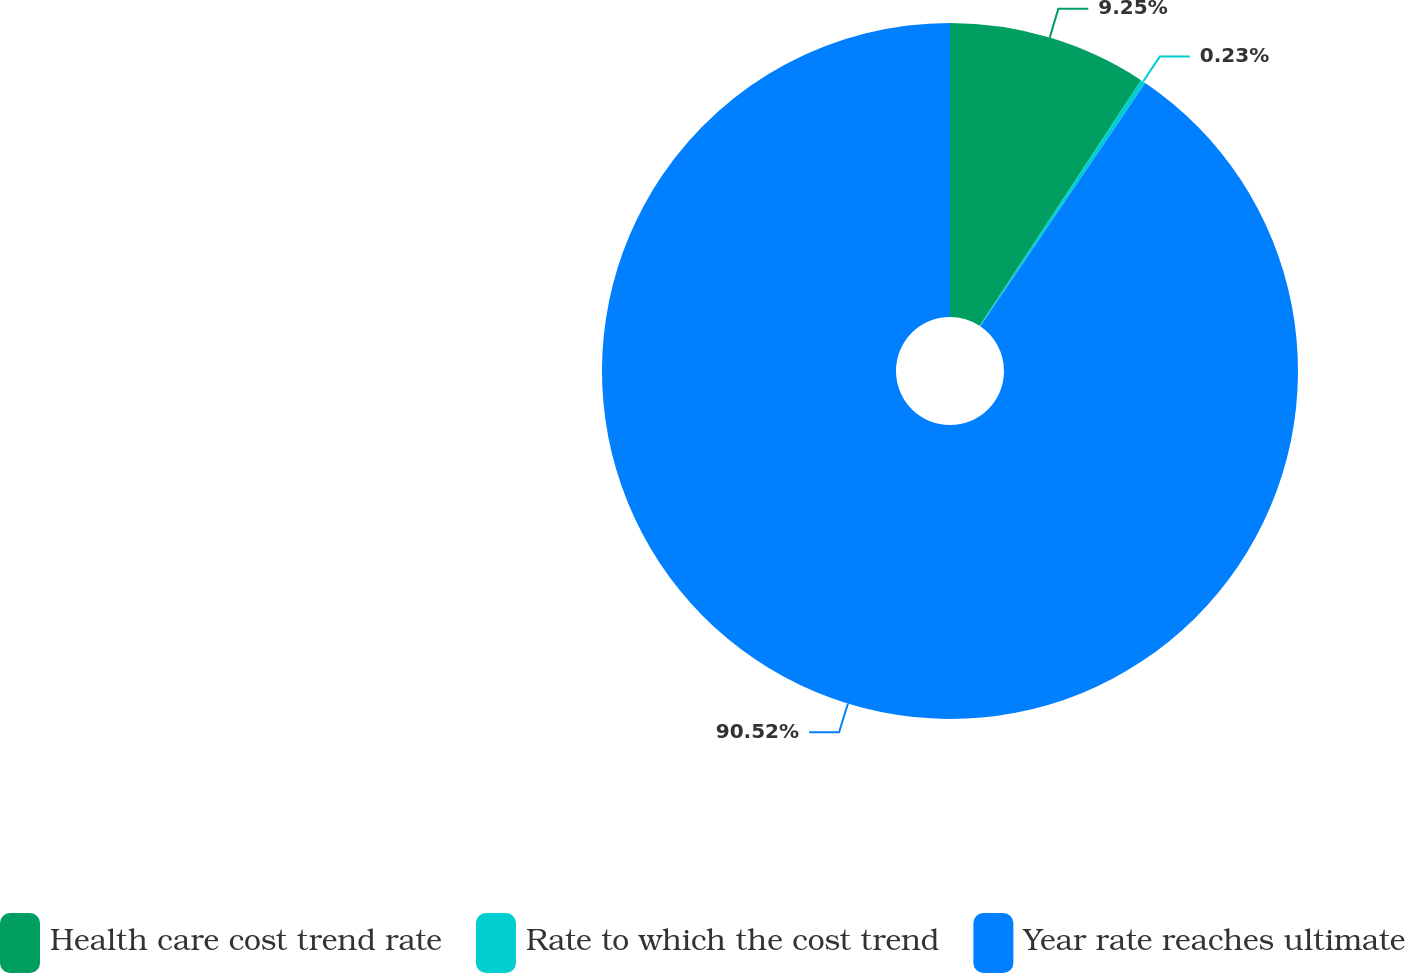Convert chart. <chart><loc_0><loc_0><loc_500><loc_500><pie_chart><fcel>Health care cost trend rate<fcel>Rate to which the cost trend<fcel>Year rate reaches ultimate<nl><fcel>9.25%<fcel>0.23%<fcel>90.52%<nl></chart> 